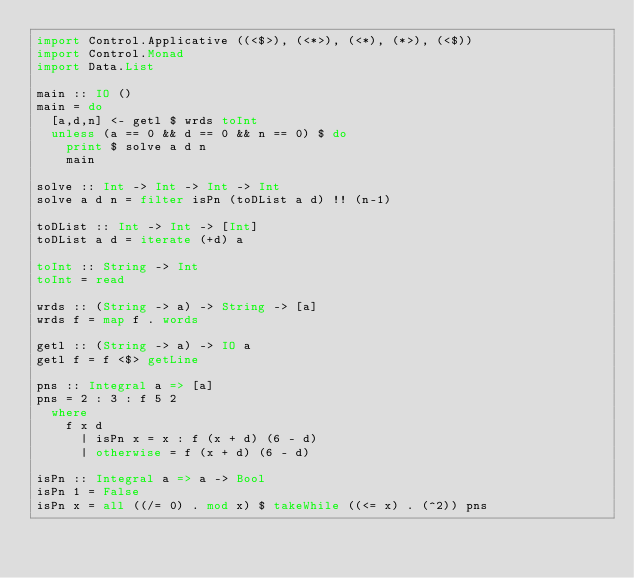<code> <loc_0><loc_0><loc_500><loc_500><_Haskell_>import Control.Applicative ((<$>), (<*>), (<*), (*>), (<$))
import Control.Monad
import Data.List

main :: IO ()
main = do
  [a,d,n] <- getl $ wrds toInt
  unless (a == 0 && d == 0 && n == 0) $ do
    print $ solve a d n
    main

solve :: Int -> Int -> Int -> Int
solve a d n = filter isPn (toDList a d) !! (n-1)

toDList :: Int -> Int -> [Int]
toDList a d = iterate (+d) a

toInt :: String -> Int
toInt = read

wrds :: (String -> a) -> String -> [a]
wrds f = map f . words

getl :: (String -> a) -> IO a
getl f = f <$> getLine

pns :: Integral a => [a]
pns = 2 : 3 : f 5 2
  where
    f x d
      | isPn x = x : f (x + d) (6 - d)
      | otherwise = f (x + d) (6 - d)

isPn :: Integral a => a -> Bool
isPn 1 = False
isPn x = all ((/= 0) . mod x) $ takeWhile ((<= x) . (^2)) pns</code> 